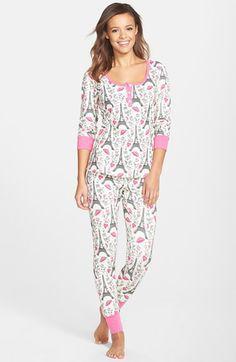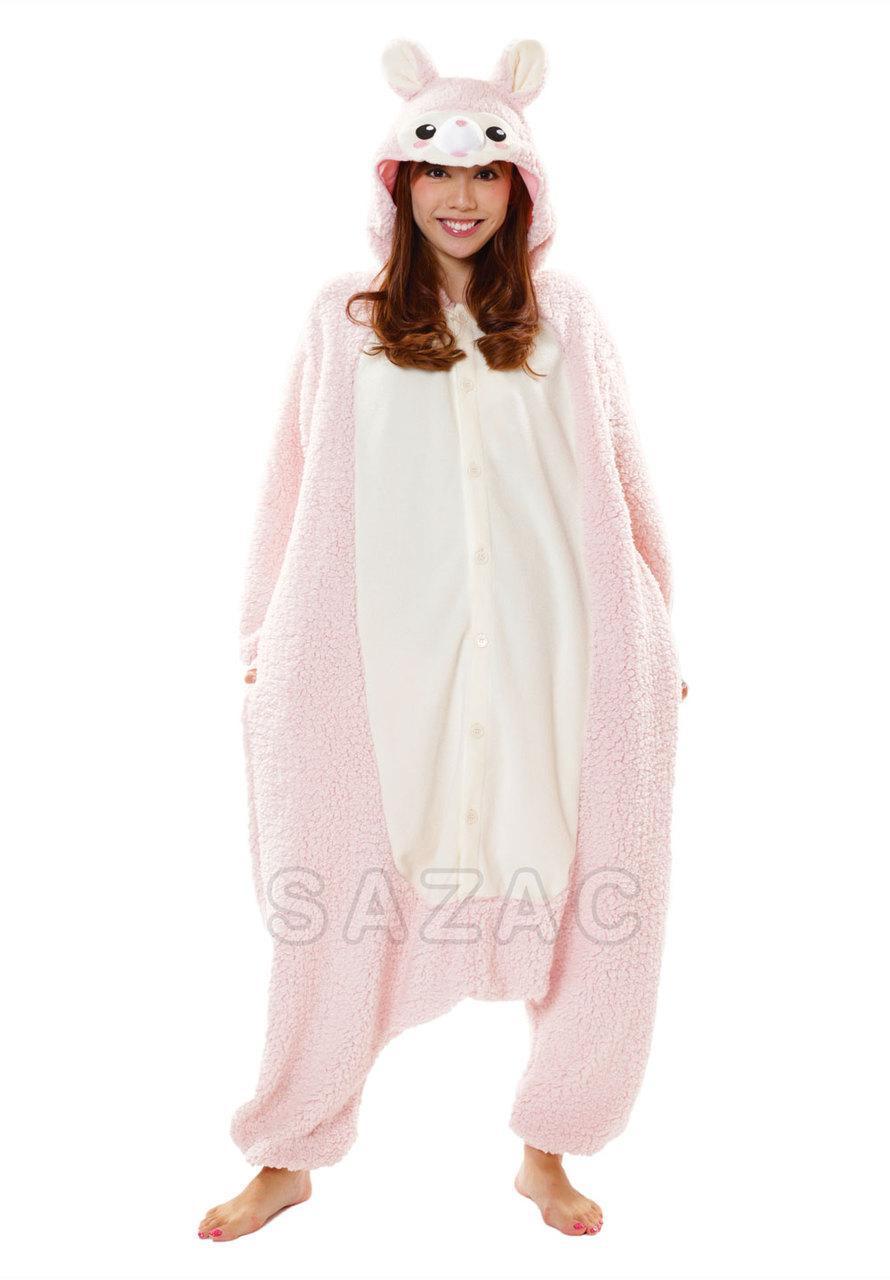The first image is the image on the left, the second image is the image on the right. Given the left and right images, does the statement "The woman in the image on the left has her feet close together." hold true? Answer yes or no. Yes. The first image is the image on the left, the second image is the image on the right. For the images shown, is this caption "An adult woman in one image is wearing a printed pajama set with tight fitting pants that have wide, solid-color cuffs at the ankles." true? Answer yes or no. Yes. 